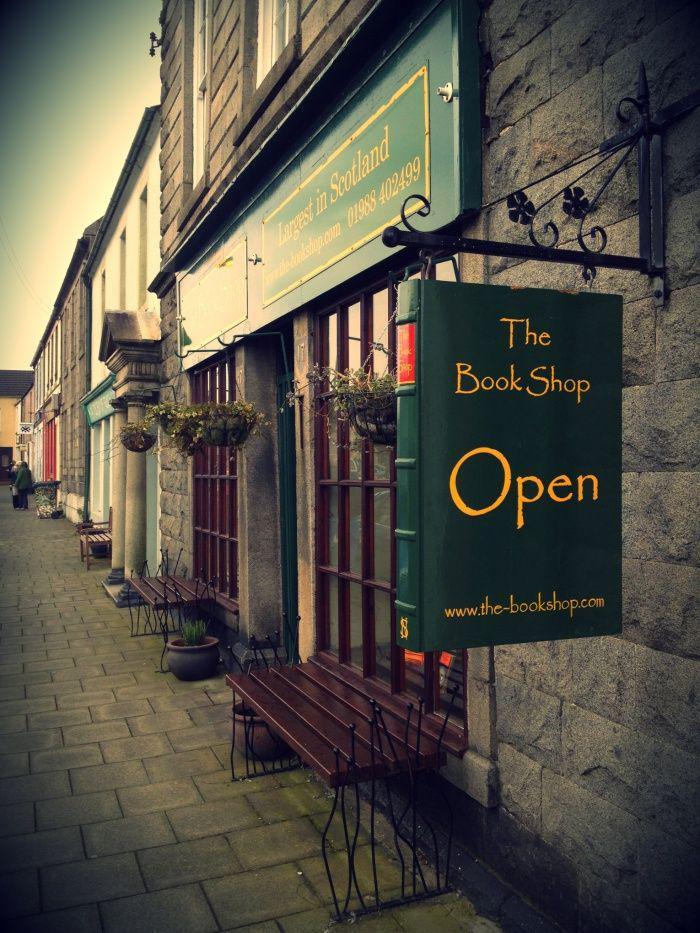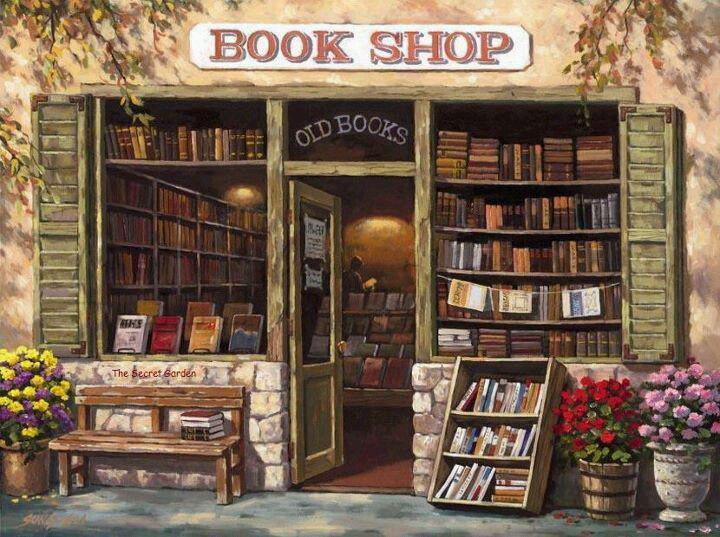The first image is the image on the left, the second image is the image on the right. Considering the images on both sides, is "The door in the right image is open." valid? Answer yes or no. Yes. The first image is the image on the left, the second image is the image on the right. For the images displayed, is the sentence "The right image shows a bookstore in the corner of a dark red brick building, with its name on black above a red door." factually correct? Answer yes or no. No. 